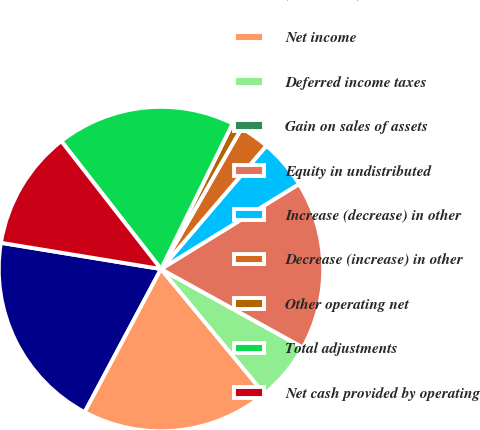<chart> <loc_0><loc_0><loc_500><loc_500><pie_chart><fcel>(in millions)<fcel>Net income<fcel>Deferred income taxes<fcel>Gain on sales of assets<fcel>Equity in undistributed<fcel>Increase (decrease) in other<fcel>Decrease (increase) in other<fcel>Other operating net<fcel>Total adjustments<fcel>Net cash provided by operating<nl><fcel>19.79%<fcel>18.8%<fcel>5.95%<fcel>0.01%<fcel>16.82%<fcel>4.96%<fcel>2.98%<fcel>1.0%<fcel>17.81%<fcel>11.88%<nl></chart> 